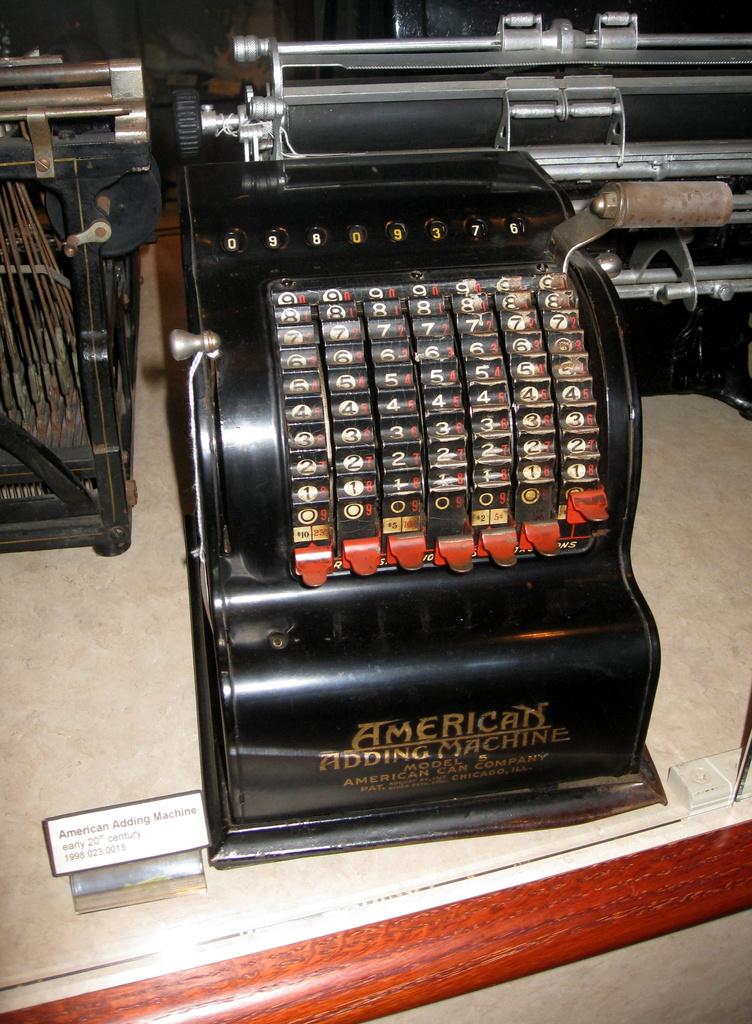What kind of machine is it?
Make the answer very short. American. 